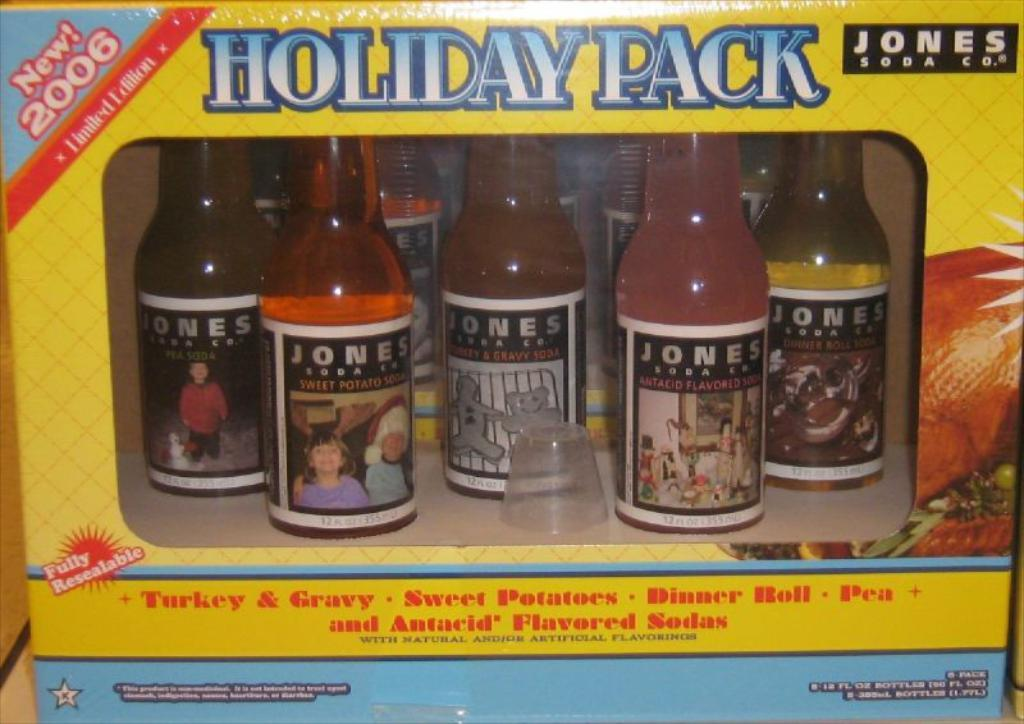Provide a one-sentence caption for the provided image. the words holiday pack are on the yellow box. 